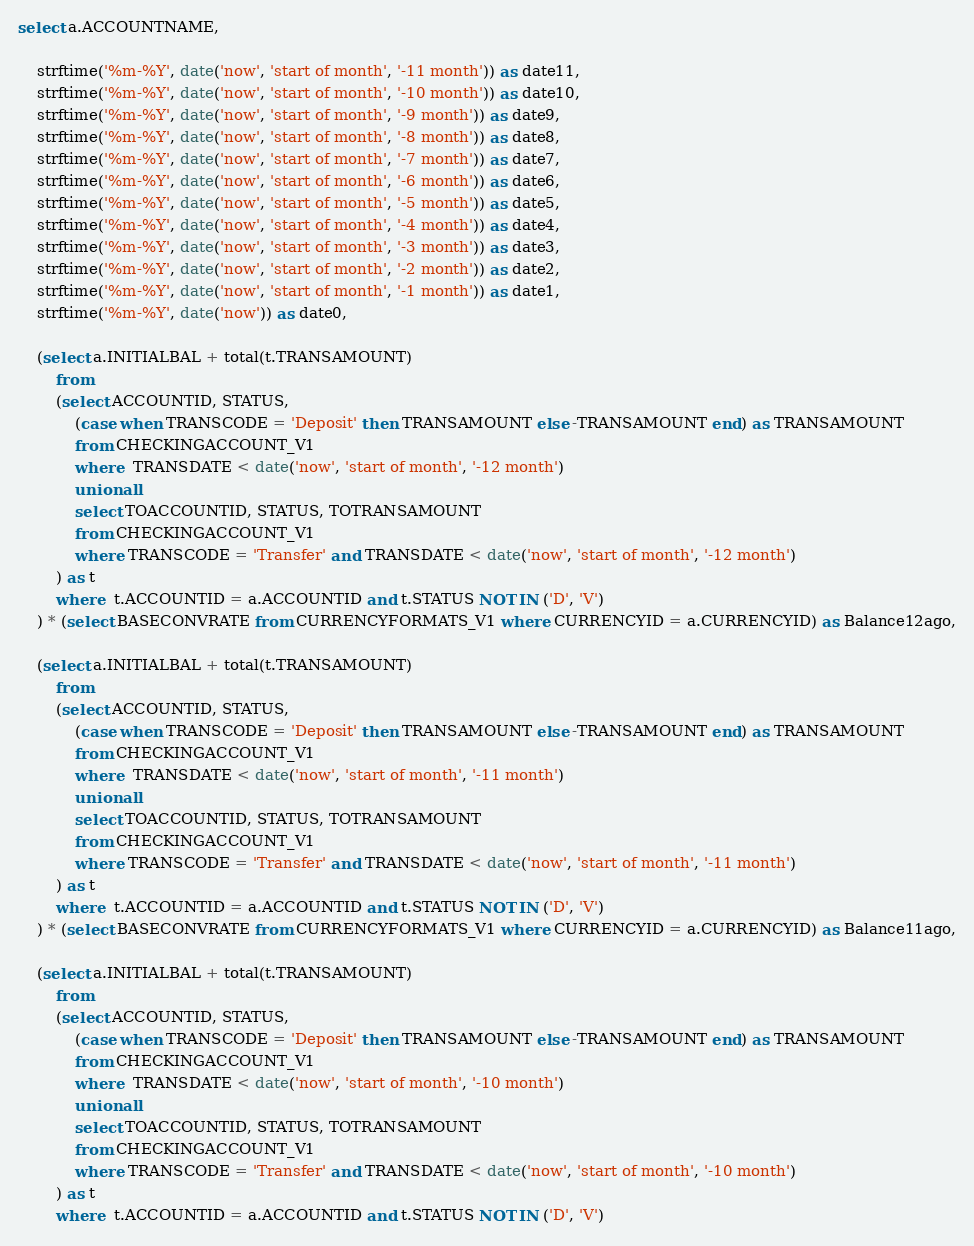<code> <loc_0><loc_0><loc_500><loc_500><_SQL_>select a.ACCOUNTNAME,

	strftime('%m-%Y', date('now', 'start of month', '-11 month')) as date11,
	strftime('%m-%Y', date('now', 'start of month', '-10 month')) as date10,
	strftime('%m-%Y', date('now', 'start of month', '-9 month')) as date9,
	strftime('%m-%Y', date('now', 'start of month', '-8 month')) as date8,
	strftime('%m-%Y', date('now', 'start of month', '-7 month')) as date7,
	strftime('%m-%Y', date('now', 'start of month', '-6 month')) as date6,
	strftime('%m-%Y', date('now', 'start of month', '-5 month')) as date5,
	strftime('%m-%Y', date('now', 'start of month', '-4 month')) as date4,
	strftime('%m-%Y', date('now', 'start of month', '-3 month')) as date3,
	strftime('%m-%Y', date('now', 'start of month', '-2 month')) as date2,
	strftime('%m-%Y', date('now', 'start of month', '-1 month')) as date1,
	strftime('%m-%Y', date('now')) as date0,

	(select a.INITIALBAL + total(t.TRANSAMOUNT)
		from
		(select ACCOUNTID, STATUS,
			(case when TRANSCODE = 'Deposit' then TRANSAMOUNT else -TRANSAMOUNT end) as TRANSAMOUNT
			from CHECKINGACCOUNT_V1
			where  TRANSDATE < date('now', 'start of month', '-12 month')
			union all
			select TOACCOUNTID, STATUS, TOTRANSAMOUNT 
			from CHECKINGACCOUNT_V1
			where TRANSCODE = 'Transfer' and TRANSDATE < date('now', 'start of month', '-12 month')
		) as t
		where  t.ACCOUNTID = a.ACCOUNTID and t.STATUS NOT IN ('D', 'V')
	) * (select BASECONVRATE from CURRENCYFORMATS_V1 where CURRENCYID = a.CURRENCYID) as Balance12ago,

	(select a.INITIALBAL + total(t.TRANSAMOUNT)
		from
		(select ACCOUNTID, STATUS,
			(case when TRANSCODE = 'Deposit' then TRANSAMOUNT else -TRANSAMOUNT end) as TRANSAMOUNT
			from CHECKINGACCOUNT_V1
			where  TRANSDATE < date('now', 'start of month', '-11 month')
			union all
			select TOACCOUNTID, STATUS, TOTRANSAMOUNT 
			from CHECKINGACCOUNT_V1
			where TRANSCODE = 'Transfer' and TRANSDATE < date('now', 'start of month', '-11 month')
		) as t
		where  t.ACCOUNTID = a.ACCOUNTID and t.STATUS NOT IN ('D', 'V')
	) * (select BASECONVRATE from CURRENCYFORMATS_V1 where CURRENCYID = a.CURRENCYID) as Balance11ago,

	(select a.INITIALBAL + total(t.TRANSAMOUNT)
		from
		(select ACCOUNTID, STATUS,
			(case when TRANSCODE = 'Deposit' then TRANSAMOUNT else -TRANSAMOUNT end) as TRANSAMOUNT
			from CHECKINGACCOUNT_V1
			where  TRANSDATE < date('now', 'start of month', '-10 month')
			union all
			select TOACCOUNTID, STATUS, TOTRANSAMOUNT 
			from CHECKINGACCOUNT_V1
			where TRANSCODE = 'Transfer' and TRANSDATE < date('now', 'start of month', '-10 month')
		) as t
		where  t.ACCOUNTID = a.ACCOUNTID and t.STATUS NOT IN ('D', 'V')</code> 